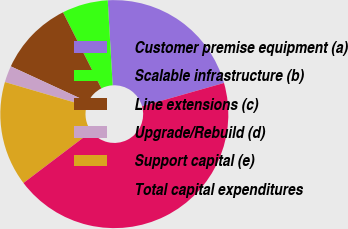<chart> <loc_0><loc_0><loc_500><loc_500><pie_chart><fcel>Customer premise equipment (a)<fcel>Scalable infrastructure (b)<fcel>Line extensions (c)<fcel>Upgrade/Rebuild (d)<fcel>Support capital (e)<fcel>Total capital expenditures<nl><fcel>21.52%<fcel>6.51%<fcel>10.69%<fcel>2.34%<fcel>14.86%<fcel>44.08%<nl></chart> 